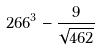Convert formula to latex. <formula><loc_0><loc_0><loc_500><loc_500>2 6 6 ^ { 3 } - \frac { 9 } { \sqrt { 4 6 2 } }</formula> 